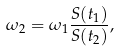Convert formula to latex. <formula><loc_0><loc_0><loc_500><loc_500>\omega _ { 2 } = \omega _ { 1 } \frac { S ( t _ { 1 } ) } { S ( t _ { 2 } ) } ,</formula> 